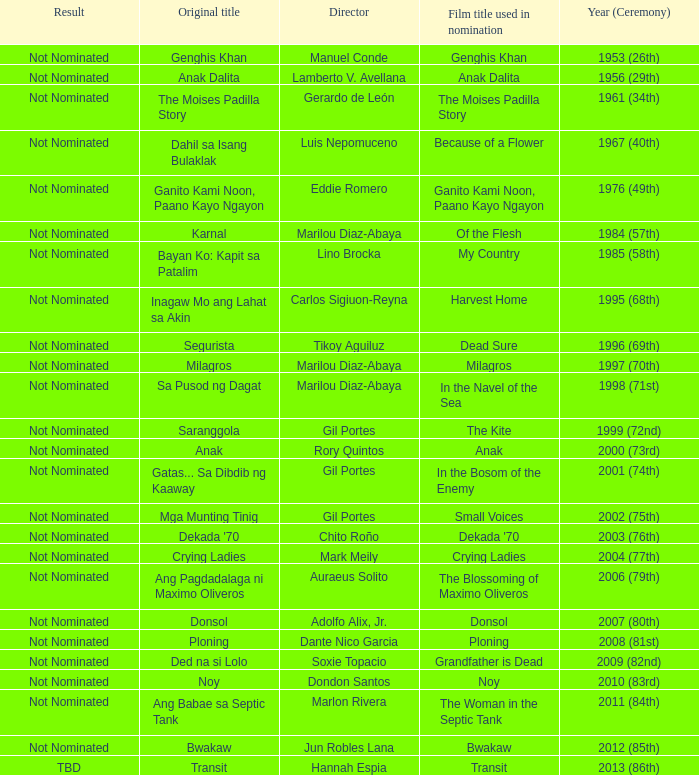What is the ceremony year when Ganito Kami Noon, Paano Kayo Ngayon was the original title? 1976 (49th). 